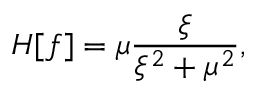Convert formula to latex. <formula><loc_0><loc_0><loc_500><loc_500>H [ f ] = \mu \frac { \xi } { \xi ^ { 2 } + \mu ^ { 2 } } ,</formula> 